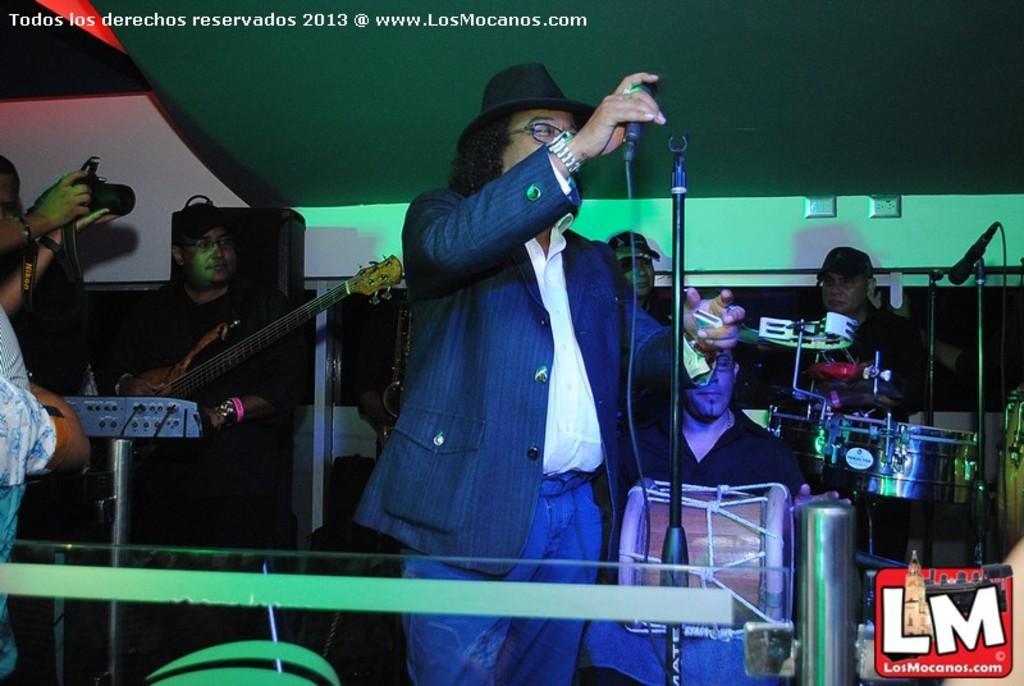Describe this image in one or two sentences. There are so many people standing on a stage playing musical instruments holding microphones. 